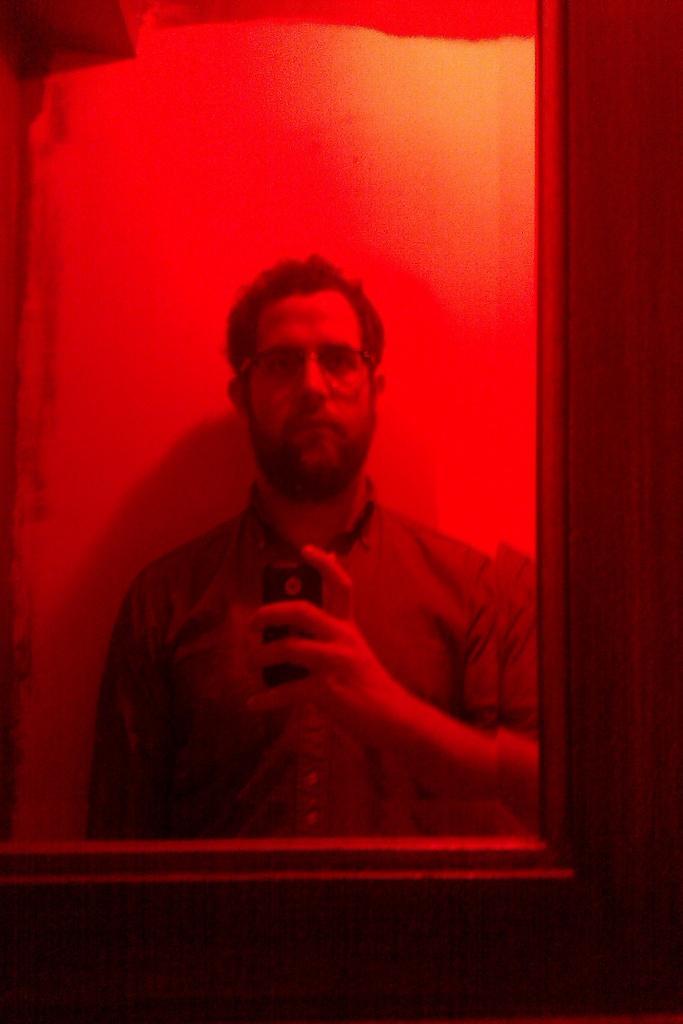In one or two sentences, can you explain what this image depicts? In this image, I can see the reflection of a person holding a mobile on the mirror, which is attached to a wooden object. 